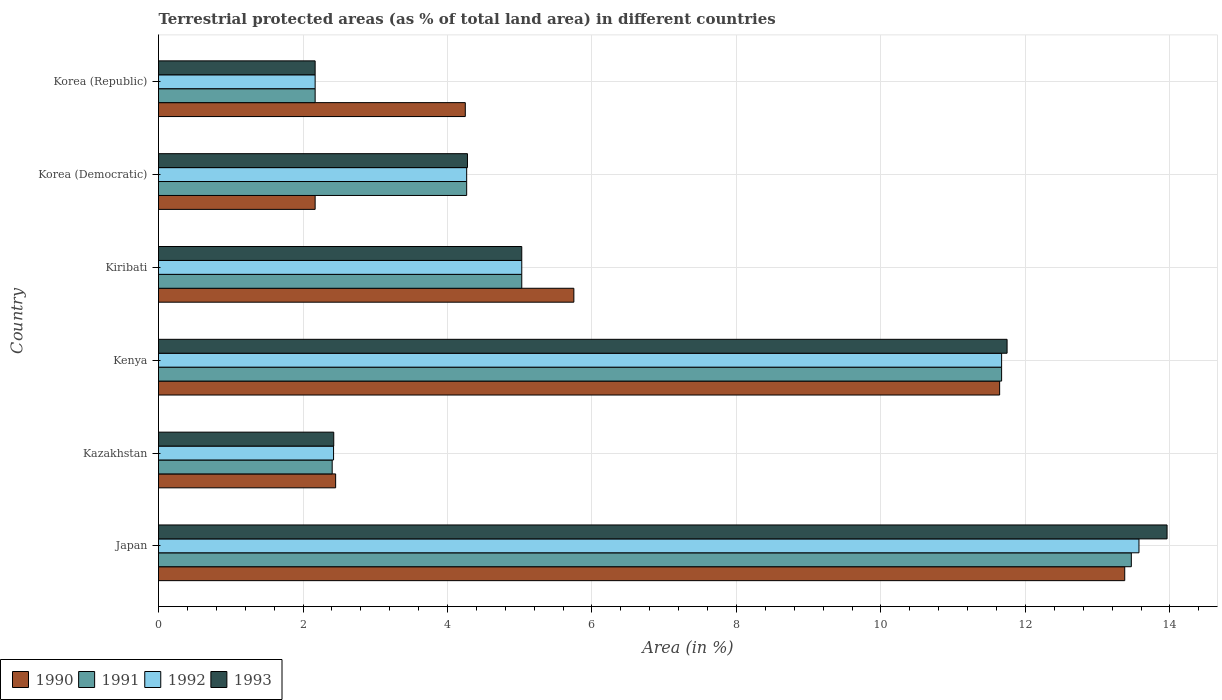How many groups of bars are there?
Provide a short and direct response. 6. Are the number of bars on each tick of the Y-axis equal?
Provide a short and direct response. Yes. How many bars are there on the 2nd tick from the top?
Ensure brevity in your answer.  4. What is the label of the 3rd group of bars from the top?
Offer a terse response. Kiribati. What is the percentage of terrestrial protected land in 1993 in Korea (Democratic)?
Offer a very short reply. 4.28. Across all countries, what is the maximum percentage of terrestrial protected land in 1991?
Make the answer very short. 13.47. Across all countries, what is the minimum percentage of terrestrial protected land in 1991?
Make the answer very short. 2.17. In which country was the percentage of terrestrial protected land in 1993 maximum?
Your response must be concise. Japan. What is the total percentage of terrestrial protected land in 1990 in the graph?
Keep it short and to the point. 39.63. What is the difference between the percentage of terrestrial protected land in 1992 in Kenya and that in Kiribati?
Your response must be concise. 6.64. What is the difference between the percentage of terrestrial protected land in 1991 in Kazakhstan and the percentage of terrestrial protected land in 1990 in Kenya?
Ensure brevity in your answer.  -9.24. What is the average percentage of terrestrial protected land in 1992 per country?
Make the answer very short. 6.52. What is the difference between the percentage of terrestrial protected land in 1993 and percentage of terrestrial protected land in 1990 in Kenya?
Your response must be concise. 0.1. In how many countries, is the percentage of terrestrial protected land in 1992 greater than 0.4 %?
Your response must be concise. 6. What is the ratio of the percentage of terrestrial protected land in 1990 in Korea (Democratic) to that in Korea (Republic)?
Offer a very short reply. 0.51. Is the percentage of terrestrial protected land in 1992 in Kenya less than that in Korea (Republic)?
Offer a very short reply. No. What is the difference between the highest and the second highest percentage of terrestrial protected land in 1992?
Make the answer very short. 1.9. What is the difference between the highest and the lowest percentage of terrestrial protected land in 1993?
Offer a terse response. 11.79. What does the 1st bar from the top in Kazakhstan represents?
Provide a short and direct response. 1993. What does the 2nd bar from the bottom in Korea (Republic) represents?
Keep it short and to the point. 1991. Is it the case that in every country, the sum of the percentage of terrestrial protected land in 1993 and percentage of terrestrial protected land in 1992 is greater than the percentage of terrestrial protected land in 1990?
Keep it short and to the point. Yes. Are all the bars in the graph horizontal?
Give a very brief answer. Yes. How many countries are there in the graph?
Provide a short and direct response. 6. Does the graph contain any zero values?
Provide a succinct answer. No. Where does the legend appear in the graph?
Provide a short and direct response. Bottom left. How many legend labels are there?
Offer a terse response. 4. What is the title of the graph?
Keep it short and to the point. Terrestrial protected areas (as % of total land area) in different countries. Does "1995" appear as one of the legend labels in the graph?
Offer a terse response. No. What is the label or title of the X-axis?
Give a very brief answer. Area (in %). What is the Area (in %) in 1990 in Japan?
Your response must be concise. 13.37. What is the Area (in %) in 1991 in Japan?
Your response must be concise. 13.47. What is the Area (in %) of 1992 in Japan?
Offer a very short reply. 13.57. What is the Area (in %) in 1993 in Japan?
Provide a succinct answer. 13.96. What is the Area (in %) of 1990 in Kazakhstan?
Your response must be concise. 2.45. What is the Area (in %) in 1991 in Kazakhstan?
Your response must be concise. 2.4. What is the Area (in %) in 1992 in Kazakhstan?
Provide a succinct answer. 2.42. What is the Area (in %) of 1993 in Kazakhstan?
Ensure brevity in your answer.  2.43. What is the Area (in %) in 1990 in Kenya?
Your response must be concise. 11.64. What is the Area (in %) of 1991 in Kenya?
Give a very brief answer. 11.67. What is the Area (in %) of 1992 in Kenya?
Make the answer very short. 11.67. What is the Area (in %) in 1993 in Kenya?
Offer a terse response. 11.75. What is the Area (in %) of 1990 in Kiribati?
Provide a short and direct response. 5.75. What is the Area (in %) of 1991 in Kiribati?
Give a very brief answer. 5.03. What is the Area (in %) in 1992 in Kiribati?
Keep it short and to the point. 5.03. What is the Area (in %) of 1993 in Kiribati?
Your answer should be very brief. 5.03. What is the Area (in %) of 1990 in Korea (Democratic)?
Your response must be concise. 2.17. What is the Area (in %) of 1991 in Korea (Democratic)?
Provide a succinct answer. 4.27. What is the Area (in %) in 1992 in Korea (Democratic)?
Provide a succinct answer. 4.27. What is the Area (in %) in 1993 in Korea (Democratic)?
Offer a terse response. 4.28. What is the Area (in %) in 1990 in Korea (Republic)?
Your answer should be very brief. 4.25. What is the Area (in %) of 1991 in Korea (Republic)?
Give a very brief answer. 2.17. What is the Area (in %) in 1992 in Korea (Republic)?
Offer a terse response. 2.17. What is the Area (in %) in 1993 in Korea (Republic)?
Make the answer very short. 2.17. Across all countries, what is the maximum Area (in %) in 1990?
Ensure brevity in your answer.  13.37. Across all countries, what is the maximum Area (in %) of 1991?
Ensure brevity in your answer.  13.47. Across all countries, what is the maximum Area (in %) in 1992?
Provide a short and direct response. 13.57. Across all countries, what is the maximum Area (in %) of 1993?
Your response must be concise. 13.96. Across all countries, what is the minimum Area (in %) in 1990?
Offer a terse response. 2.17. Across all countries, what is the minimum Area (in %) of 1991?
Give a very brief answer. 2.17. Across all countries, what is the minimum Area (in %) in 1992?
Offer a terse response. 2.17. Across all countries, what is the minimum Area (in %) in 1993?
Keep it short and to the point. 2.17. What is the total Area (in %) in 1990 in the graph?
Keep it short and to the point. 39.63. What is the total Area (in %) in 1991 in the graph?
Provide a short and direct response. 39. What is the total Area (in %) of 1992 in the graph?
Ensure brevity in your answer.  39.13. What is the total Area (in %) in 1993 in the graph?
Offer a terse response. 39.61. What is the difference between the Area (in %) of 1990 in Japan and that in Kazakhstan?
Ensure brevity in your answer.  10.92. What is the difference between the Area (in %) in 1991 in Japan and that in Kazakhstan?
Make the answer very short. 11.06. What is the difference between the Area (in %) in 1992 in Japan and that in Kazakhstan?
Your answer should be very brief. 11.15. What is the difference between the Area (in %) of 1993 in Japan and that in Kazakhstan?
Your response must be concise. 11.54. What is the difference between the Area (in %) of 1990 in Japan and that in Kenya?
Ensure brevity in your answer.  1.73. What is the difference between the Area (in %) of 1991 in Japan and that in Kenya?
Your answer should be compact. 1.8. What is the difference between the Area (in %) of 1992 in Japan and that in Kenya?
Your answer should be very brief. 1.9. What is the difference between the Area (in %) in 1993 in Japan and that in Kenya?
Your answer should be compact. 2.21. What is the difference between the Area (in %) of 1990 in Japan and that in Kiribati?
Provide a short and direct response. 7.63. What is the difference between the Area (in %) of 1991 in Japan and that in Kiribati?
Make the answer very short. 8.44. What is the difference between the Area (in %) of 1992 in Japan and that in Kiribati?
Provide a succinct answer. 8.54. What is the difference between the Area (in %) of 1993 in Japan and that in Kiribati?
Provide a short and direct response. 8.93. What is the difference between the Area (in %) of 1990 in Japan and that in Korea (Democratic)?
Provide a succinct answer. 11.21. What is the difference between the Area (in %) of 1991 in Japan and that in Korea (Democratic)?
Make the answer very short. 9.2. What is the difference between the Area (in %) in 1992 in Japan and that in Korea (Democratic)?
Offer a very short reply. 9.31. What is the difference between the Area (in %) in 1993 in Japan and that in Korea (Democratic)?
Give a very brief answer. 9.68. What is the difference between the Area (in %) of 1990 in Japan and that in Korea (Republic)?
Your answer should be very brief. 9.13. What is the difference between the Area (in %) in 1991 in Japan and that in Korea (Republic)?
Provide a short and direct response. 11.3. What is the difference between the Area (in %) of 1992 in Japan and that in Korea (Republic)?
Keep it short and to the point. 11.4. What is the difference between the Area (in %) in 1993 in Japan and that in Korea (Republic)?
Offer a terse response. 11.79. What is the difference between the Area (in %) of 1990 in Kazakhstan and that in Kenya?
Keep it short and to the point. -9.19. What is the difference between the Area (in %) in 1991 in Kazakhstan and that in Kenya?
Offer a terse response. -9.27. What is the difference between the Area (in %) of 1992 in Kazakhstan and that in Kenya?
Provide a short and direct response. -9.25. What is the difference between the Area (in %) of 1993 in Kazakhstan and that in Kenya?
Ensure brevity in your answer.  -9.32. What is the difference between the Area (in %) in 1990 in Kazakhstan and that in Kiribati?
Make the answer very short. -3.3. What is the difference between the Area (in %) in 1991 in Kazakhstan and that in Kiribati?
Offer a very short reply. -2.62. What is the difference between the Area (in %) in 1992 in Kazakhstan and that in Kiribati?
Give a very brief answer. -2.61. What is the difference between the Area (in %) in 1993 in Kazakhstan and that in Kiribati?
Your answer should be compact. -2.6. What is the difference between the Area (in %) of 1990 in Kazakhstan and that in Korea (Democratic)?
Make the answer very short. 0.28. What is the difference between the Area (in %) of 1991 in Kazakhstan and that in Korea (Democratic)?
Keep it short and to the point. -1.86. What is the difference between the Area (in %) in 1992 in Kazakhstan and that in Korea (Democratic)?
Your answer should be compact. -1.84. What is the difference between the Area (in %) of 1993 in Kazakhstan and that in Korea (Democratic)?
Provide a succinct answer. -1.85. What is the difference between the Area (in %) in 1990 in Kazakhstan and that in Korea (Republic)?
Offer a very short reply. -1.79. What is the difference between the Area (in %) of 1991 in Kazakhstan and that in Korea (Republic)?
Keep it short and to the point. 0.24. What is the difference between the Area (in %) of 1992 in Kazakhstan and that in Korea (Republic)?
Your answer should be compact. 0.26. What is the difference between the Area (in %) of 1993 in Kazakhstan and that in Korea (Republic)?
Offer a terse response. 0.26. What is the difference between the Area (in %) in 1990 in Kenya and that in Kiribati?
Offer a terse response. 5.89. What is the difference between the Area (in %) in 1991 in Kenya and that in Kiribati?
Provide a short and direct response. 6.64. What is the difference between the Area (in %) of 1992 in Kenya and that in Kiribati?
Keep it short and to the point. 6.64. What is the difference between the Area (in %) in 1993 in Kenya and that in Kiribati?
Give a very brief answer. 6.72. What is the difference between the Area (in %) in 1990 in Kenya and that in Korea (Democratic)?
Your answer should be compact. 9.47. What is the difference between the Area (in %) of 1991 in Kenya and that in Korea (Democratic)?
Offer a very short reply. 7.4. What is the difference between the Area (in %) of 1992 in Kenya and that in Korea (Democratic)?
Your answer should be very brief. 7.4. What is the difference between the Area (in %) in 1993 in Kenya and that in Korea (Democratic)?
Offer a very short reply. 7.47. What is the difference between the Area (in %) of 1990 in Kenya and that in Korea (Republic)?
Make the answer very short. 7.4. What is the difference between the Area (in %) of 1991 in Kenya and that in Korea (Republic)?
Keep it short and to the point. 9.5. What is the difference between the Area (in %) in 1992 in Kenya and that in Korea (Republic)?
Give a very brief answer. 9.5. What is the difference between the Area (in %) in 1993 in Kenya and that in Korea (Republic)?
Offer a very short reply. 9.58. What is the difference between the Area (in %) of 1990 in Kiribati and that in Korea (Democratic)?
Ensure brevity in your answer.  3.58. What is the difference between the Area (in %) of 1991 in Kiribati and that in Korea (Democratic)?
Provide a short and direct response. 0.76. What is the difference between the Area (in %) in 1992 in Kiribati and that in Korea (Democratic)?
Give a very brief answer. 0.76. What is the difference between the Area (in %) in 1993 in Kiribati and that in Korea (Democratic)?
Give a very brief answer. 0.75. What is the difference between the Area (in %) of 1990 in Kiribati and that in Korea (Republic)?
Keep it short and to the point. 1.5. What is the difference between the Area (in %) of 1991 in Kiribati and that in Korea (Republic)?
Your response must be concise. 2.86. What is the difference between the Area (in %) of 1992 in Kiribati and that in Korea (Republic)?
Ensure brevity in your answer.  2.86. What is the difference between the Area (in %) of 1993 in Kiribati and that in Korea (Republic)?
Give a very brief answer. 2.86. What is the difference between the Area (in %) of 1990 in Korea (Democratic) and that in Korea (Republic)?
Keep it short and to the point. -2.08. What is the difference between the Area (in %) of 1991 in Korea (Democratic) and that in Korea (Republic)?
Offer a very short reply. 2.1. What is the difference between the Area (in %) of 1992 in Korea (Democratic) and that in Korea (Republic)?
Your response must be concise. 2.1. What is the difference between the Area (in %) in 1993 in Korea (Democratic) and that in Korea (Republic)?
Make the answer very short. 2.11. What is the difference between the Area (in %) in 1990 in Japan and the Area (in %) in 1991 in Kazakhstan?
Keep it short and to the point. 10.97. What is the difference between the Area (in %) of 1990 in Japan and the Area (in %) of 1992 in Kazakhstan?
Your answer should be compact. 10.95. What is the difference between the Area (in %) in 1990 in Japan and the Area (in %) in 1993 in Kazakhstan?
Provide a short and direct response. 10.95. What is the difference between the Area (in %) of 1991 in Japan and the Area (in %) of 1992 in Kazakhstan?
Offer a very short reply. 11.04. What is the difference between the Area (in %) in 1991 in Japan and the Area (in %) in 1993 in Kazakhstan?
Keep it short and to the point. 11.04. What is the difference between the Area (in %) of 1992 in Japan and the Area (in %) of 1993 in Kazakhstan?
Provide a short and direct response. 11.15. What is the difference between the Area (in %) in 1990 in Japan and the Area (in %) in 1991 in Kenya?
Offer a very short reply. 1.7. What is the difference between the Area (in %) in 1990 in Japan and the Area (in %) in 1992 in Kenya?
Ensure brevity in your answer.  1.7. What is the difference between the Area (in %) in 1990 in Japan and the Area (in %) in 1993 in Kenya?
Offer a very short reply. 1.63. What is the difference between the Area (in %) in 1991 in Japan and the Area (in %) in 1992 in Kenya?
Offer a very short reply. 1.8. What is the difference between the Area (in %) of 1991 in Japan and the Area (in %) of 1993 in Kenya?
Your answer should be compact. 1.72. What is the difference between the Area (in %) of 1992 in Japan and the Area (in %) of 1993 in Kenya?
Provide a short and direct response. 1.83. What is the difference between the Area (in %) of 1990 in Japan and the Area (in %) of 1991 in Kiribati?
Your answer should be compact. 8.35. What is the difference between the Area (in %) of 1990 in Japan and the Area (in %) of 1992 in Kiribati?
Keep it short and to the point. 8.35. What is the difference between the Area (in %) in 1990 in Japan and the Area (in %) in 1993 in Kiribati?
Your response must be concise. 8.35. What is the difference between the Area (in %) in 1991 in Japan and the Area (in %) in 1992 in Kiribati?
Offer a terse response. 8.44. What is the difference between the Area (in %) of 1991 in Japan and the Area (in %) of 1993 in Kiribati?
Make the answer very short. 8.44. What is the difference between the Area (in %) in 1992 in Japan and the Area (in %) in 1993 in Kiribati?
Your answer should be compact. 8.54. What is the difference between the Area (in %) in 1990 in Japan and the Area (in %) in 1991 in Korea (Democratic)?
Offer a very short reply. 9.11. What is the difference between the Area (in %) in 1990 in Japan and the Area (in %) in 1992 in Korea (Democratic)?
Your answer should be compact. 9.11. What is the difference between the Area (in %) of 1990 in Japan and the Area (in %) of 1993 in Korea (Democratic)?
Offer a terse response. 9.1. What is the difference between the Area (in %) in 1991 in Japan and the Area (in %) in 1992 in Korea (Democratic)?
Provide a short and direct response. 9.2. What is the difference between the Area (in %) in 1991 in Japan and the Area (in %) in 1993 in Korea (Democratic)?
Your answer should be very brief. 9.19. What is the difference between the Area (in %) of 1992 in Japan and the Area (in %) of 1993 in Korea (Democratic)?
Give a very brief answer. 9.3. What is the difference between the Area (in %) of 1990 in Japan and the Area (in %) of 1991 in Korea (Republic)?
Keep it short and to the point. 11.21. What is the difference between the Area (in %) of 1990 in Japan and the Area (in %) of 1992 in Korea (Republic)?
Your answer should be compact. 11.21. What is the difference between the Area (in %) in 1990 in Japan and the Area (in %) in 1993 in Korea (Republic)?
Make the answer very short. 11.21. What is the difference between the Area (in %) in 1991 in Japan and the Area (in %) in 1992 in Korea (Republic)?
Provide a succinct answer. 11.3. What is the difference between the Area (in %) of 1991 in Japan and the Area (in %) of 1993 in Korea (Republic)?
Your response must be concise. 11.3. What is the difference between the Area (in %) in 1992 in Japan and the Area (in %) in 1993 in Korea (Republic)?
Your answer should be very brief. 11.4. What is the difference between the Area (in %) of 1990 in Kazakhstan and the Area (in %) of 1991 in Kenya?
Ensure brevity in your answer.  -9.22. What is the difference between the Area (in %) in 1990 in Kazakhstan and the Area (in %) in 1992 in Kenya?
Your answer should be compact. -9.22. What is the difference between the Area (in %) of 1990 in Kazakhstan and the Area (in %) of 1993 in Kenya?
Offer a very short reply. -9.29. What is the difference between the Area (in %) in 1991 in Kazakhstan and the Area (in %) in 1992 in Kenya?
Offer a terse response. -9.27. What is the difference between the Area (in %) of 1991 in Kazakhstan and the Area (in %) of 1993 in Kenya?
Provide a succinct answer. -9.34. What is the difference between the Area (in %) of 1992 in Kazakhstan and the Area (in %) of 1993 in Kenya?
Offer a very short reply. -9.32. What is the difference between the Area (in %) in 1990 in Kazakhstan and the Area (in %) in 1991 in Kiribati?
Provide a succinct answer. -2.58. What is the difference between the Area (in %) of 1990 in Kazakhstan and the Area (in %) of 1992 in Kiribati?
Offer a very short reply. -2.58. What is the difference between the Area (in %) of 1990 in Kazakhstan and the Area (in %) of 1993 in Kiribati?
Your response must be concise. -2.58. What is the difference between the Area (in %) of 1991 in Kazakhstan and the Area (in %) of 1992 in Kiribati?
Your answer should be compact. -2.62. What is the difference between the Area (in %) of 1991 in Kazakhstan and the Area (in %) of 1993 in Kiribati?
Offer a terse response. -2.62. What is the difference between the Area (in %) of 1992 in Kazakhstan and the Area (in %) of 1993 in Kiribati?
Your response must be concise. -2.61. What is the difference between the Area (in %) of 1990 in Kazakhstan and the Area (in %) of 1991 in Korea (Democratic)?
Your response must be concise. -1.81. What is the difference between the Area (in %) in 1990 in Kazakhstan and the Area (in %) in 1992 in Korea (Democratic)?
Provide a short and direct response. -1.81. What is the difference between the Area (in %) in 1990 in Kazakhstan and the Area (in %) in 1993 in Korea (Democratic)?
Your answer should be very brief. -1.82. What is the difference between the Area (in %) of 1991 in Kazakhstan and the Area (in %) of 1992 in Korea (Democratic)?
Make the answer very short. -1.86. What is the difference between the Area (in %) of 1991 in Kazakhstan and the Area (in %) of 1993 in Korea (Democratic)?
Make the answer very short. -1.87. What is the difference between the Area (in %) in 1992 in Kazakhstan and the Area (in %) in 1993 in Korea (Democratic)?
Provide a succinct answer. -1.85. What is the difference between the Area (in %) in 1990 in Kazakhstan and the Area (in %) in 1991 in Korea (Republic)?
Your response must be concise. 0.28. What is the difference between the Area (in %) of 1990 in Kazakhstan and the Area (in %) of 1992 in Korea (Republic)?
Your answer should be very brief. 0.28. What is the difference between the Area (in %) in 1990 in Kazakhstan and the Area (in %) in 1993 in Korea (Republic)?
Provide a short and direct response. 0.28. What is the difference between the Area (in %) in 1991 in Kazakhstan and the Area (in %) in 1992 in Korea (Republic)?
Offer a terse response. 0.24. What is the difference between the Area (in %) of 1991 in Kazakhstan and the Area (in %) of 1993 in Korea (Republic)?
Ensure brevity in your answer.  0.24. What is the difference between the Area (in %) of 1992 in Kazakhstan and the Area (in %) of 1993 in Korea (Republic)?
Provide a succinct answer. 0.26. What is the difference between the Area (in %) of 1990 in Kenya and the Area (in %) of 1991 in Kiribati?
Offer a terse response. 6.61. What is the difference between the Area (in %) of 1990 in Kenya and the Area (in %) of 1992 in Kiribati?
Ensure brevity in your answer.  6.61. What is the difference between the Area (in %) of 1990 in Kenya and the Area (in %) of 1993 in Kiribati?
Ensure brevity in your answer.  6.61. What is the difference between the Area (in %) of 1991 in Kenya and the Area (in %) of 1992 in Kiribati?
Ensure brevity in your answer.  6.64. What is the difference between the Area (in %) of 1991 in Kenya and the Area (in %) of 1993 in Kiribati?
Make the answer very short. 6.64. What is the difference between the Area (in %) in 1992 in Kenya and the Area (in %) in 1993 in Kiribati?
Make the answer very short. 6.64. What is the difference between the Area (in %) of 1990 in Kenya and the Area (in %) of 1991 in Korea (Democratic)?
Make the answer very short. 7.38. What is the difference between the Area (in %) in 1990 in Kenya and the Area (in %) in 1992 in Korea (Democratic)?
Offer a terse response. 7.38. What is the difference between the Area (in %) in 1990 in Kenya and the Area (in %) in 1993 in Korea (Democratic)?
Ensure brevity in your answer.  7.37. What is the difference between the Area (in %) in 1991 in Kenya and the Area (in %) in 1992 in Korea (Democratic)?
Your response must be concise. 7.4. What is the difference between the Area (in %) of 1991 in Kenya and the Area (in %) of 1993 in Korea (Democratic)?
Make the answer very short. 7.39. What is the difference between the Area (in %) of 1992 in Kenya and the Area (in %) of 1993 in Korea (Democratic)?
Offer a very short reply. 7.39. What is the difference between the Area (in %) in 1990 in Kenya and the Area (in %) in 1991 in Korea (Republic)?
Make the answer very short. 9.47. What is the difference between the Area (in %) in 1990 in Kenya and the Area (in %) in 1992 in Korea (Republic)?
Keep it short and to the point. 9.47. What is the difference between the Area (in %) in 1990 in Kenya and the Area (in %) in 1993 in Korea (Republic)?
Keep it short and to the point. 9.47. What is the difference between the Area (in %) of 1991 in Kenya and the Area (in %) of 1992 in Korea (Republic)?
Ensure brevity in your answer.  9.5. What is the difference between the Area (in %) in 1991 in Kenya and the Area (in %) in 1993 in Korea (Republic)?
Offer a terse response. 9.5. What is the difference between the Area (in %) of 1992 in Kenya and the Area (in %) of 1993 in Korea (Republic)?
Your answer should be very brief. 9.5. What is the difference between the Area (in %) in 1990 in Kiribati and the Area (in %) in 1991 in Korea (Democratic)?
Provide a short and direct response. 1.48. What is the difference between the Area (in %) of 1990 in Kiribati and the Area (in %) of 1992 in Korea (Democratic)?
Keep it short and to the point. 1.48. What is the difference between the Area (in %) of 1990 in Kiribati and the Area (in %) of 1993 in Korea (Democratic)?
Provide a short and direct response. 1.47. What is the difference between the Area (in %) in 1991 in Kiribati and the Area (in %) in 1992 in Korea (Democratic)?
Make the answer very short. 0.76. What is the difference between the Area (in %) of 1991 in Kiribati and the Area (in %) of 1993 in Korea (Democratic)?
Ensure brevity in your answer.  0.75. What is the difference between the Area (in %) in 1992 in Kiribati and the Area (in %) in 1993 in Korea (Democratic)?
Make the answer very short. 0.75. What is the difference between the Area (in %) in 1990 in Kiribati and the Area (in %) in 1991 in Korea (Republic)?
Make the answer very short. 3.58. What is the difference between the Area (in %) of 1990 in Kiribati and the Area (in %) of 1992 in Korea (Republic)?
Make the answer very short. 3.58. What is the difference between the Area (in %) in 1990 in Kiribati and the Area (in %) in 1993 in Korea (Republic)?
Provide a short and direct response. 3.58. What is the difference between the Area (in %) in 1991 in Kiribati and the Area (in %) in 1992 in Korea (Republic)?
Provide a short and direct response. 2.86. What is the difference between the Area (in %) in 1991 in Kiribati and the Area (in %) in 1993 in Korea (Republic)?
Your response must be concise. 2.86. What is the difference between the Area (in %) of 1992 in Kiribati and the Area (in %) of 1993 in Korea (Republic)?
Keep it short and to the point. 2.86. What is the difference between the Area (in %) of 1990 in Korea (Democratic) and the Area (in %) of 1991 in Korea (Republic)?
Provide a succinct answer. 0. What is the difference between the Area (in %) in 1990 in Korea (Democratic) and the Area (in %) in 1993 in Korea (Republic)?
Make the answer very short. 0. What is the difference between the Area (in %) of 1991 in Korea (Democratic) and the Area (in %) of 1992 in Korea (Republic)?
Ensure brevity in your answer.  2.1. What is the difference between the Area (in %) of 1991 in Korea (Democratic) and the Area (in %) of 1993 in Korea (Republic)?
Provide a succinct answer. 2.1. What is the difference between the Area (in %) of 1992 in Korea (Democratic) and the Area (in %) of 1993 in Korea (Republic)?
Your answer should be compact. 2.1. What is the average Area (in %) of 1990 per country?
Give a very brief answer. 6.61. What is the average Area (in %) in 1991 per country?
Your answer should be very brief. 6.5. What is the average Area (in %) in 1992 per country?
Ensure brevity in your answer.  6.52. What is the average Area (in %) in 1993 per country?
Offer a terse response. 6.6. What is the difference between the Area (in %) in 1990 and Area (in %) in 1991 in Japan?
Your response must be concise. -0.09. What is the difference between the Area (in %) of 1990 and Area (in %) of 1992 in Japan?
Your answer should be compact. -0.2. What is the difference between the Area (in %) of 1990 and Area (in %) of 1993 in Japan?
Make the answer very short. -0.59. What is the difference between the Area (in %) of 1991 and Area (in %) of 1992 in Japan?
Provide a short and direct response. -0.11. What is the difference between the Area (in %) of 1991 and Area (in %) of 1993 in Japan?
Ensure brevity in your answer.  -0.49. What is the difference between the Area (in %) of 1992 and Area (in %) of 1993 in Japan?
Provide a succinct answer. -0.39. What is the difference between the Area (in %) of 1990 and Area (in %) of 1991 in Kazakhstan?
Your answer should be compact. 0.05. What is the difference between the Area (in %) in 1990 and Area (in %) in 1992 in Kazakhstan?
Keep it short and to the point. 0.03. What is the difference between the Area (in %) in 1990 and Area (in %) in 1993 in Kazakhstan?
Provide a succinct answer. 0.03. What is the difference between the Area (in %) of 1991 and Area (in %) of 1992 in Kazakhstan?
Make the answer very short. -0.02. What is the difference between the Area (in %) of 1991 and Area (in %) of 1993 in Kazakhstan?
Keep it short and to the point. -0.02. What is the difference between the Area (in %) in 1992 and Area (in %) in 1993 in Kazakhstan?
Keep it short and to the point. -0. What is the difference between the Area (in %) in 1990 and Area (in %) in 1991 in Kenya?
Provide a short and direct response. -0.03. What is the difference between the Area (in %) of 1990 and Area (in %) of 1992 in Kenya?
Your answer should be compact. -0.03. What is the difference between the Area (in %) of 1990 and Area (in %) of 1993 in Kenya?
Keep it short and to the point. -0.1. What is the difference between the Area (in %) of 1991 and Area (in %) of 1992 in Kenya?
Provide a succinct answer. -0. What is the difference between the Area (in %) of 1991 and Area (in %) of 1993 in Kenya?
Offer a terse response. -0.08. What is the difference between the Area (in %) of 1992 and Area (in %) of 1993 in Kenya?
Offer a very short reply. -0.08. What is the difference between the Area (in %) in 1990 and Area (in %) in 1991 in Kiribati?
Make the answer very short. 0.72. What is the difference between the Area (in %) of 1990 and Area (in %) of 1992 in Kiribati?
Your answer should be compact. 0.72. What is the difference between the Area (in %) in 1990 and Area (in %) in 1993 in Kiribati?
Offer a very short reply. 0.72. What is the difference between the Area (in %) in 1991 and Area (in %) in 1993 in Kiribati?
Ensure brevity in your answer.  0. What is the difference between the Area (in %) in 1992 and Area (in %) in 1993 in Kiribati?
Offer a very short reply. 0. What is the difference between the Area (in %) of 1990 and Area (in %) of 1991 in Korea (Democratic)?
Your answer should be compact. -2.1. What is the difference between the Area (in %) in 1990 and Area (in %) in 1992 in Korea (Democratic)?
Provide a short and direct response. -2.1. What is the difference between the Area (in %) of 1990 and Area (in %) of 1993 in Korea (Democratic)?
Offer a very short reply. -2.11. What is the difference between the Area (in %) in 1991 and Area (in %) in 1993 in Korea (Democratic)?
Offer a very short reply. -0.01. What is the difference between the Area (in %) in 1992 and Area (in %) in 1993 in Korea (Democratic)?
Give a very brief answer. -0.01. What is the difference between the Area (in %) in 1990 and Area (in %) in 1991 in Korea (Republic)?
Your answer should be compact. 2.08. What is the difference between the Area (in %) of 1990 and Area (in %) of 1992 in Korea (Republic)?
Your response must be concise. 2.08. What is the difference between the Area (in %) in 1990 and Area (in %) in 1993 in Korea (Republic)?
Your response must be concise. 2.08. What is the ratio of the Area (in %) of 1990 in Japan to that in Kazakhstan?
Provide a succinct answer. 5.45. What is the ratio of the Area (in %) of 1991 in Japan to that in Kazakhstan?
Ensure brevity in your answer.  5.6. What is the ratio of the Area (in %) in 1992 in Japan to that in Kazakhstan?
Your response must be concise. 5.6. What is the ratio of the Area (in %) in 1993 in Japan to that in Kazakhstan?
Provide a succinct answer. 5.76. What is the ratio of the Area (in %) of 1990 in Japan to that in Kenya?
Offer a very short reply. 1.15. What is the ratio of the Area (in %) of 1991 in Japan to that in Kenya?
Provide a succinct answer. 1.15. What is the ratio of the Area (in %) in 1992 in Japan to that in Kenya?
Your answer should be compact. 1.16. What is the ratio of the Area (in %) in 1993 in Japan to that in Kenya?
Your answer should be compact. 1.19. What is the ratio of the Area (in %) in 1990 in Japan to that in Kiribati?
Your response must be concise. 2.33. What is the ratio of the Area (in %) in 1991 in Japan to that in Kiribati?
Make the answer very short. 2.68. What is the ratio of the Area (in %) in 1992 in Japan to that in Kiribati?
Provide a succinct answer. 2.7. What is the ratio of the Area (in %) of 1993 in Japan to that in Kiribati?
Your answer should be compact. 2.78. What is the ratio of the Area (in %) of 1990 in Japan to that in Korea (Democratic)?
Your response must be concise. 6.17. What is the ratio of the Area (in %) of 1991 in Japan to that in Korea (Democratic)?
Your response must be concise. 3.16. What is the ratio of the Area (in %) of 1992 in Japan to that in Korea (Democratic)?
Keep it short and to the point. 3.18. What is the ratio of the Area (in %) in 1993 in Japan to that in Korea (Democratic)?
Keep it short and to the point. 3.26. What is the ratio of the Area (in %) in 1990 in Japan to that in Korea (Republic)?
Give a very brief answer. 3.15. What is the ratio of the Area (in %) in 1991 in Japan to that in Korea (Republic)?
Give a very brief answer. 6.21. What is the ratio of the Area (in %) of 1992 in Japan to that in Korea (Republic)?
Provide a succinct answer. 6.26. What is the ratio of the Area (in %) of 1993 in Japan to that in Korea (Republic)?
Give a very brief answer. 6.44. What is the ratio of the Area (in %) of 1990 in Kazakhstan to that in Kenya?
Your answer should be very brief. 0.21. What is the ratio of the Area (in %) in 1991 in Kazakhstan to that in Kenya?
Your answer should be compact. 0.21. What is the ratio of the Area (in %) of 1992 in Kazakhstan to that in Kenya?
Your response must be concise. 0.21. What is the ratio of the Area (in %) of 1993 in Kazakhstan to that in Kenya?
Your answer should be very brief. 0.21. What is the ratio of the Area (in %) in 1990 in Kazakhstan to that in Kiribati?
Make the answer very short. 0.43. What is the ratio of the Area (in %) of 1991 in Kazakhstan to that in Kiribati?
Make the answer very short. 0.48. What is the ratio of the Area (in %) of 1992 in Kazakhstan to that in Kiribati?
Make the answer very short. 0.48. What is the ratio of the Area (in %) in 1993 in Kazakhstan to that in Kiribati?
Provide a succinct answer. 0.48. What is the ratio of the Area (in %) of 1990 in Kazakhstan to that in Korea (Democratic)?
Offer a very short reply. 1.13. What is the ratio of the Area (in %) of 1991 in Kazakhstan to that in Korea (Democratic)?
Keep it short and to the point. 0.56. What is the ratio of the Area (in %) of 1992 in Kazakhstan to that in Korea (Democratic)?
Give a very brief answer. 0.57. What is the ratio of the Area (in %) of 1993 in Kazakhstan to that in Korea (Democratic)?
Your answer should be compact. 0.57. What is the ratio of the Area (in %) in 1990 in Kazakhstan to that in Korea (Republic)?
Your response must be concise. 0.58. What is the ratio of the Area (in %) in 1991 in Kazakhstan to that in Korea (Republic)?
Your answer should be very brief. 1.11. What is the ratio of the Area (in %) in 1992 in Kazakhstan to that in Korea (Republic)?
Ensure brevity in your answer.  1.12. What is the ratio of the Area (in %) of 1993 in Kazakhstan to that in Korea (Republic)?
Provide a succinct answer. 1.12. What is the ratio of the Area (in %) of 1990 in Kenya to that in Kiribati?
Provide a short and direct response. 2.03. What is the ratio of the Area (in %) in 1991 in Kenya to that in Kiribati?
Offer a terse response. 2.32. What is the ratio of the Area (in %) of 1992 in Kenya to that in Kiribati?
Provide a short and direct response. 2.32. What is the ratio of the Area (in %) of 1993 in Kenya to that in Kiribati?
Offer a terse response. 2.34. What is the ratio of the Area (in %) of 1990 in Kenya to that in Korea (Democratic)?
Offer a terse response. 5.37. What is the ratio of the Area (in %) in 1991 in Kenya to that in Korea (Democratic)?
Offer a very short reply. 2.74. What is the ratio of the Area (in %) in 1992 in Kenya to that in Korea (Democratic)?
Offer a terse response. 2.74. What is the ratio of the Area (in %) in 1993 in Kenya to that in Korea (Democratic)?
Offer a very short reply. 2.75. What is the ratio of the Area (in %) in 1990 in Kenya to that in Korea (Republic)?
Provide a succinct answer. 2.74. What is the ratio of the Area (in %) of 1991 in Kenya to that in Korea (Republic)?
Make the answer very short. 5.38. What is the ratio of the Area (in %) of 1992 in Kenya to that in Korea (Republic)?
Offer a terse response. 5.38. What is the ratio of the Area (in %) in 1993 in Kenya to that in Korea (Republic)?
Offer a very short reply. 5.42. What is the ratio of the Area (in %) in 1990 in Kiribati to that in Korea (Democratic)?
Your answer should be very brief. 2.65. What is the ratio of the Area (in %) in 1991 in Kiribati to that in Korea (Democratic)?
Your answer should be compact. 1.18. What is the ratio of the Area (in %) in 1992 in Kiribati to that in Korea (Democratic)?
Keep it short and to the point. 1.18. What is the ratio of the Area (in %) of 1993 in Kiribati to that in Korea (Democratic)?
Your answer should be compact. 1.18. What is the ratio of the Area (in %) of 1990 in Kiribati to that in Korea (Republic)?
Keep it short and to the point. 1.35. What is the ratio of the Area (in %) of 1991 in Kiribati to that in Korea (Republic)?
Ensure brevity in your answer.  2.32. What is the ratio of the Area (in %) of 1992 in Kiribati to that in Korea (Republic)?
Give a very brief answer. 2.32. What is the ratio of the Area (in %) in 1993 in Kiribati to that in Korea (Republic)?
Offer a very short reply. 2.32. What is the ratio of the Area (in %) in 1990 in Korea (Democratic) to that in Korea (Republic)?
Keep it short and to the point. 0.51. What is the ratio of the Area (in %) in 1991 in Korea (Democratic) to that in Korea (Republic)?
Give a very brief answer. 1.97. What is the ratio of the Area (in %) of 1992 in Korea (Democratic) to that in Korea (Republic)?
Make the answer very short. 1.97. What is the ratio of the Area (in %) of 1993 in Korea (Democratic) to that in Korea (Republic)?
Offer a terse response. 1.97. What is the difference between the highest and the second highest Area (in %) in 1990?
Offer a very short reply. 1.73. What is the difference between the highest and the second highest Area (in %) in 1991?
Offer a very short reply. 1.8. What is the difference between the highest and the second highest Area (in %) in 1992?
Keep it short and to the point. 1.9. What is the difference between the highest and the second highest Area (in %) in 1993?
Keep it short and to the point. 2.21. What is the difference between the highest and the lowest Area (in %) of 1990?
Keep it short and to the point. 11.21. What is the difference between the highest and the lowest Area (in %) of 1991?
Give a very brief answer. 11.3. What is the difference between the highest and the lowest Area (in %) of 1992?
Your answer should be very brief. 11.4. What is the difference between the highest and the lowest Area (in %) in 1993?
Your answer should be very brief. 11.79. 